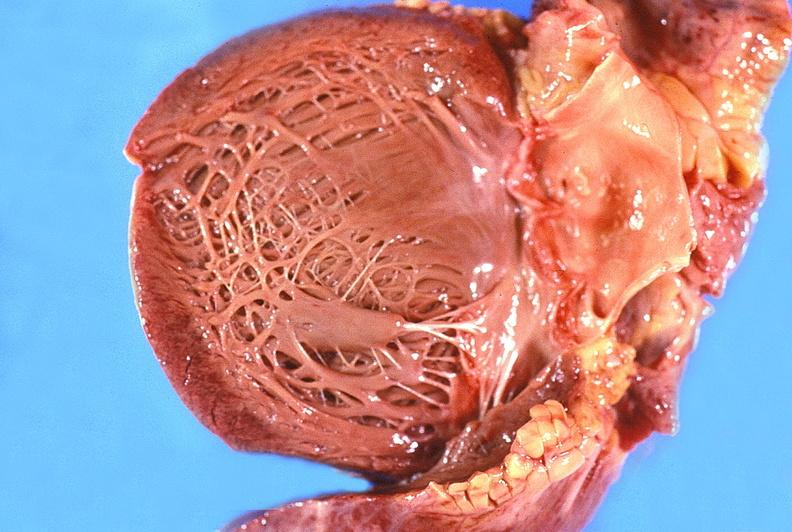what is present?
Answer the question using a single word or phrase. Cardiovascular 